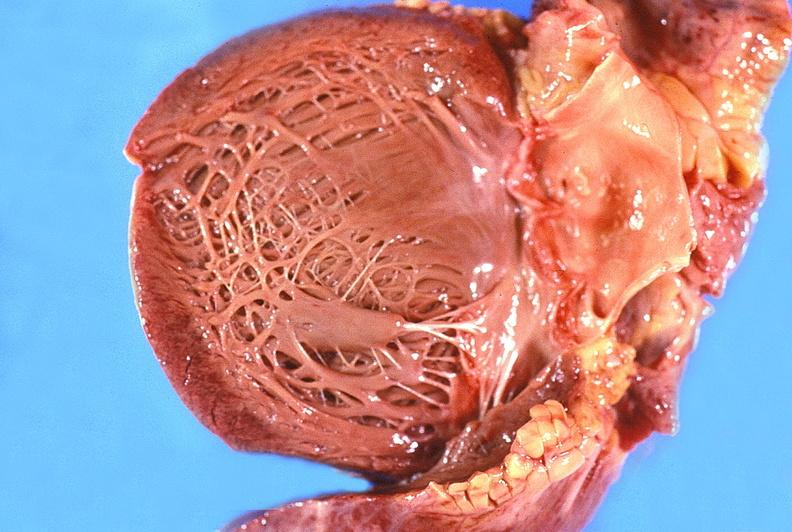what is present?
Answer the question using a single word or phrase. Cardiovascular 